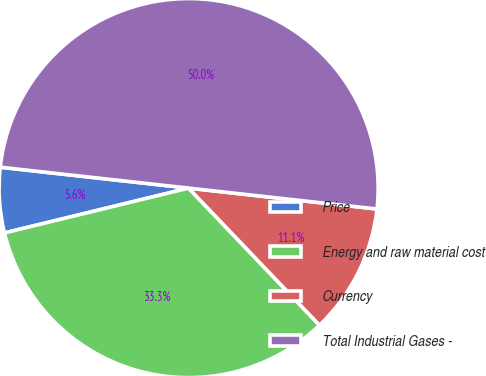Convert chart to OTSL. <chart><loc_0><loc_0><loc_500><loc_500><pie_chart><fcel>Price<fcel>Energy and raw material cost<fcel>Currency<fcel>Total Industrial Gases -<nl><fcel>5.56%<fcel>33.33%<fcel>11.11%<fcel>50.0%<nl></chart> 